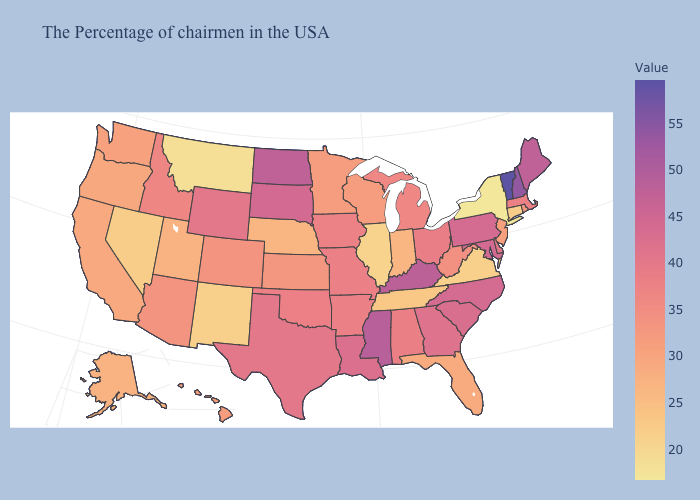Among the states that border Oklahoma , does Texas have the highest value?
Be succinct. Yes. Which states hav the highest value in the South?
Keep it brief. Mississippi. Does New Mexico have the lowest value in the West?
Be succinct. No. Is the legend a continuous bar?
Concise answer only. Yes. Among the states that border Kentucky , which have the highest value?
Be succinct. Ohio. Among the states that border Wisconsin , does Iowa have the lowest value?
Keep it brief. No. 